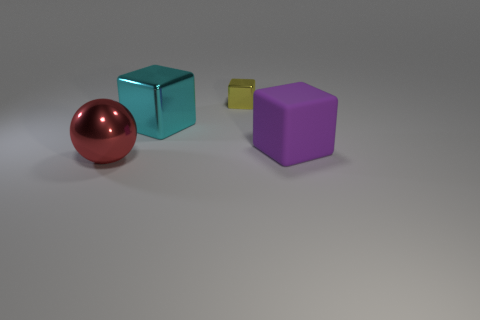If these objects were part of a set, what kind of set could it be? It looks like they could be part of an educational set designed to teach about colors, shapes, and sizes. With their simple yet distinct forms and colors, they're ideal for visual learning exercises, particularly for young children. 